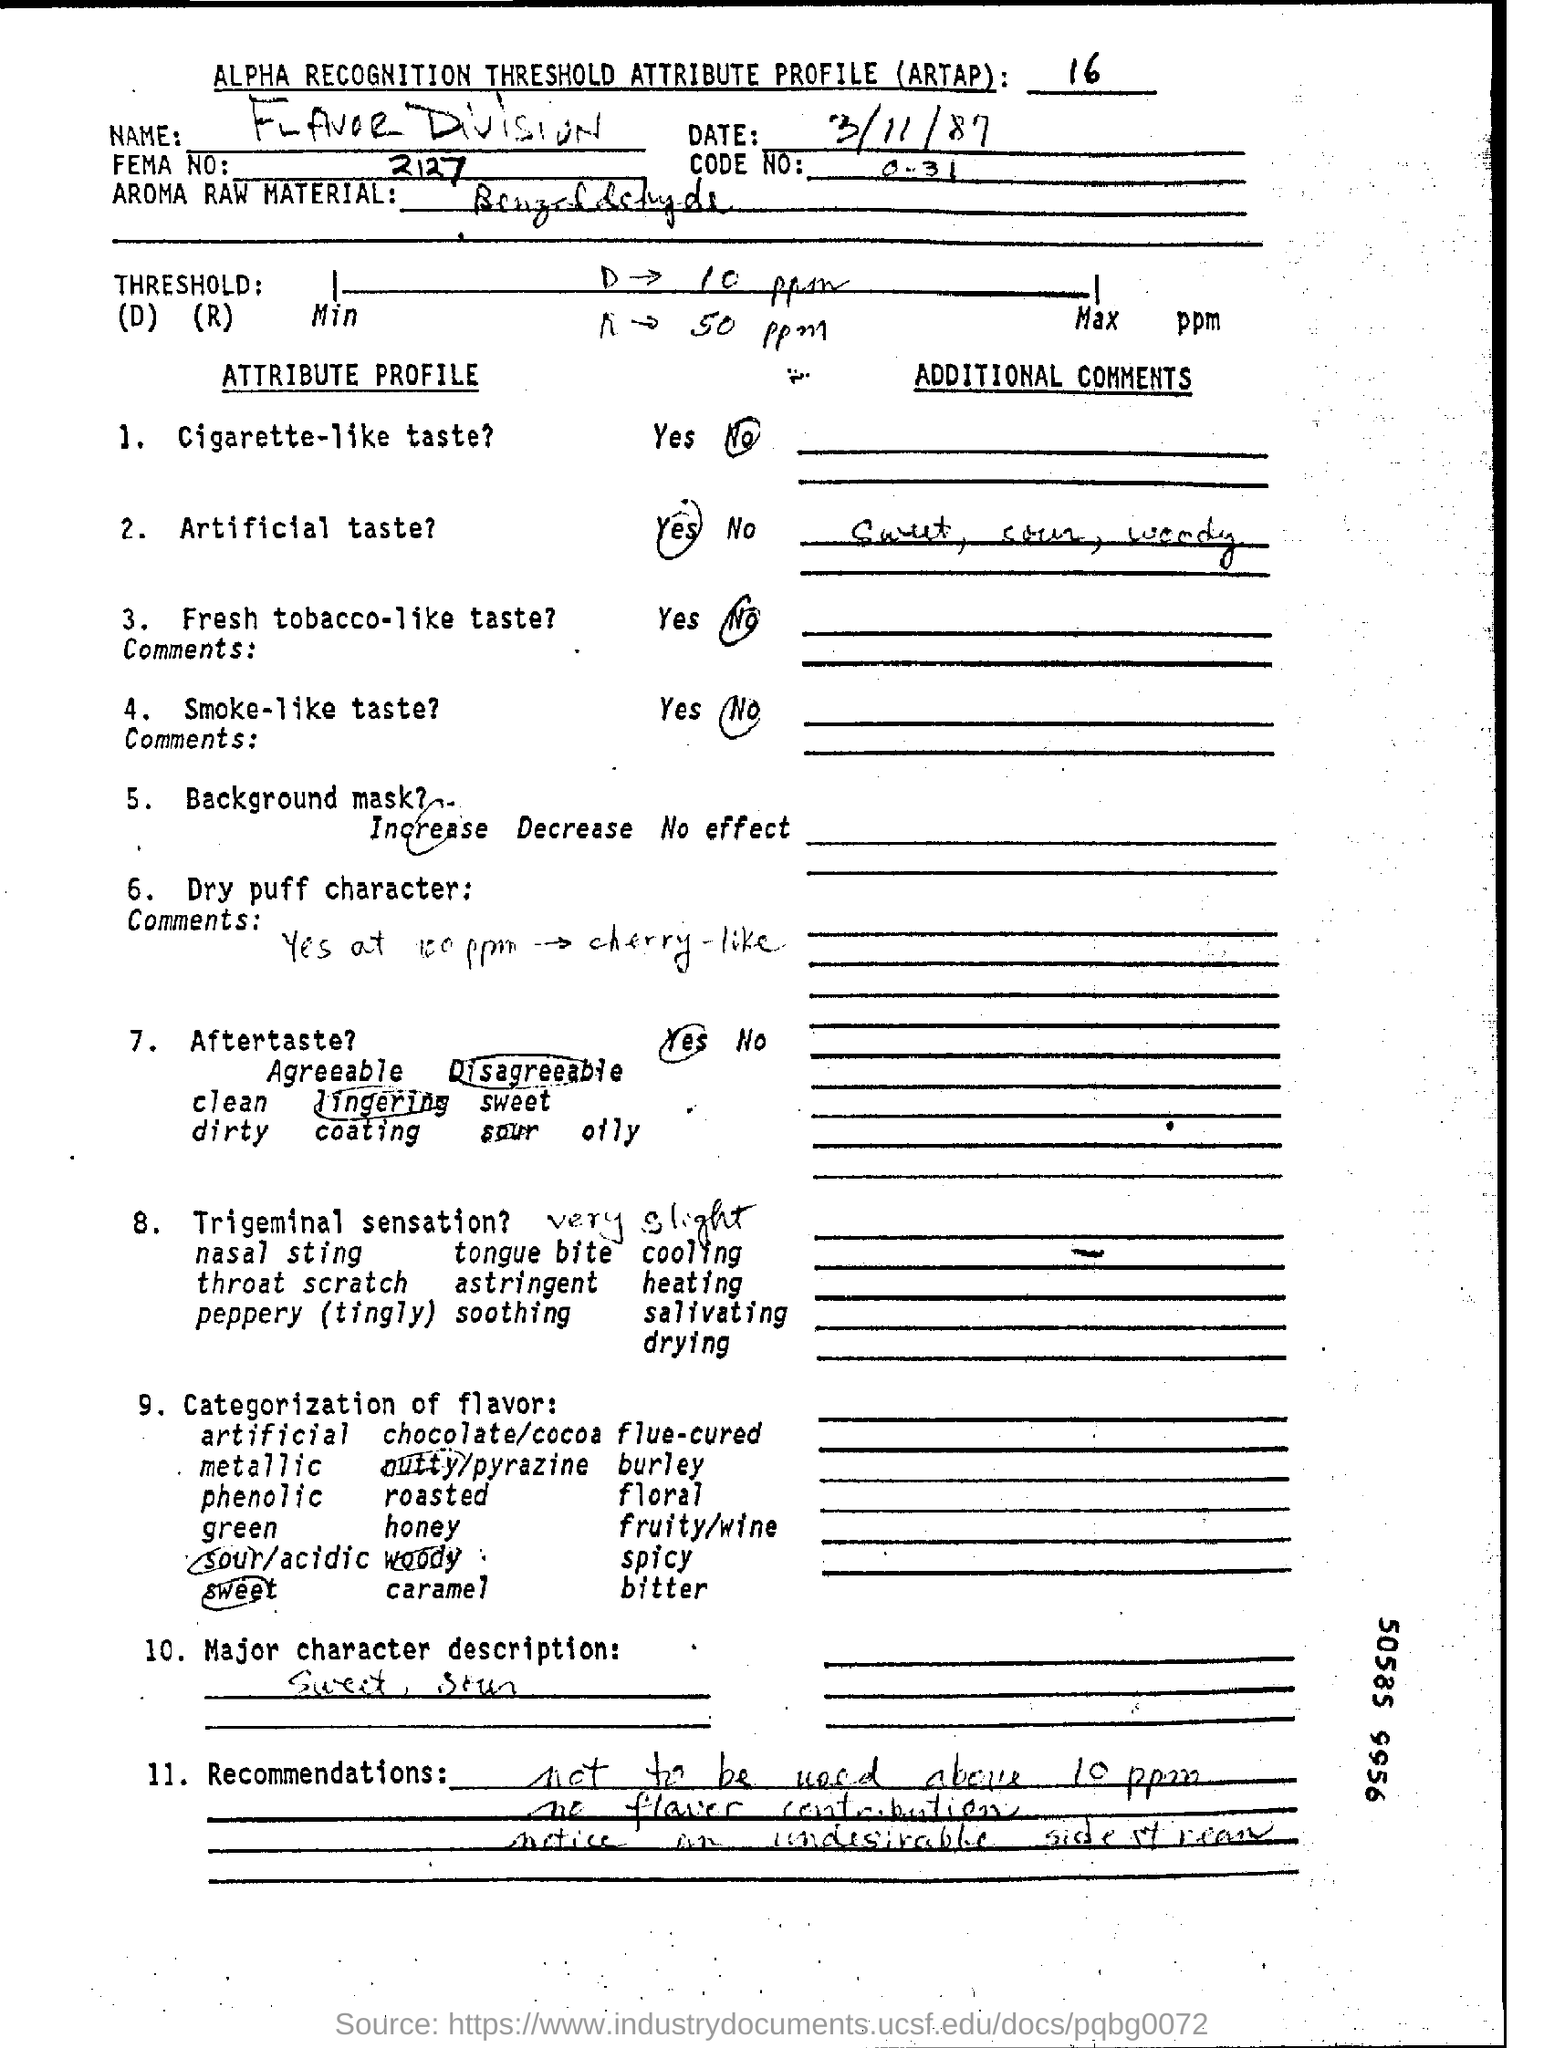What is the date mentioned in the top of the document ?
Your answer should be compact. 3/11/87. What is the Code Number ?
Keep it short and to the point. 0-31. What is the FEMA Number ?
Your answer should be compact. 2127. 